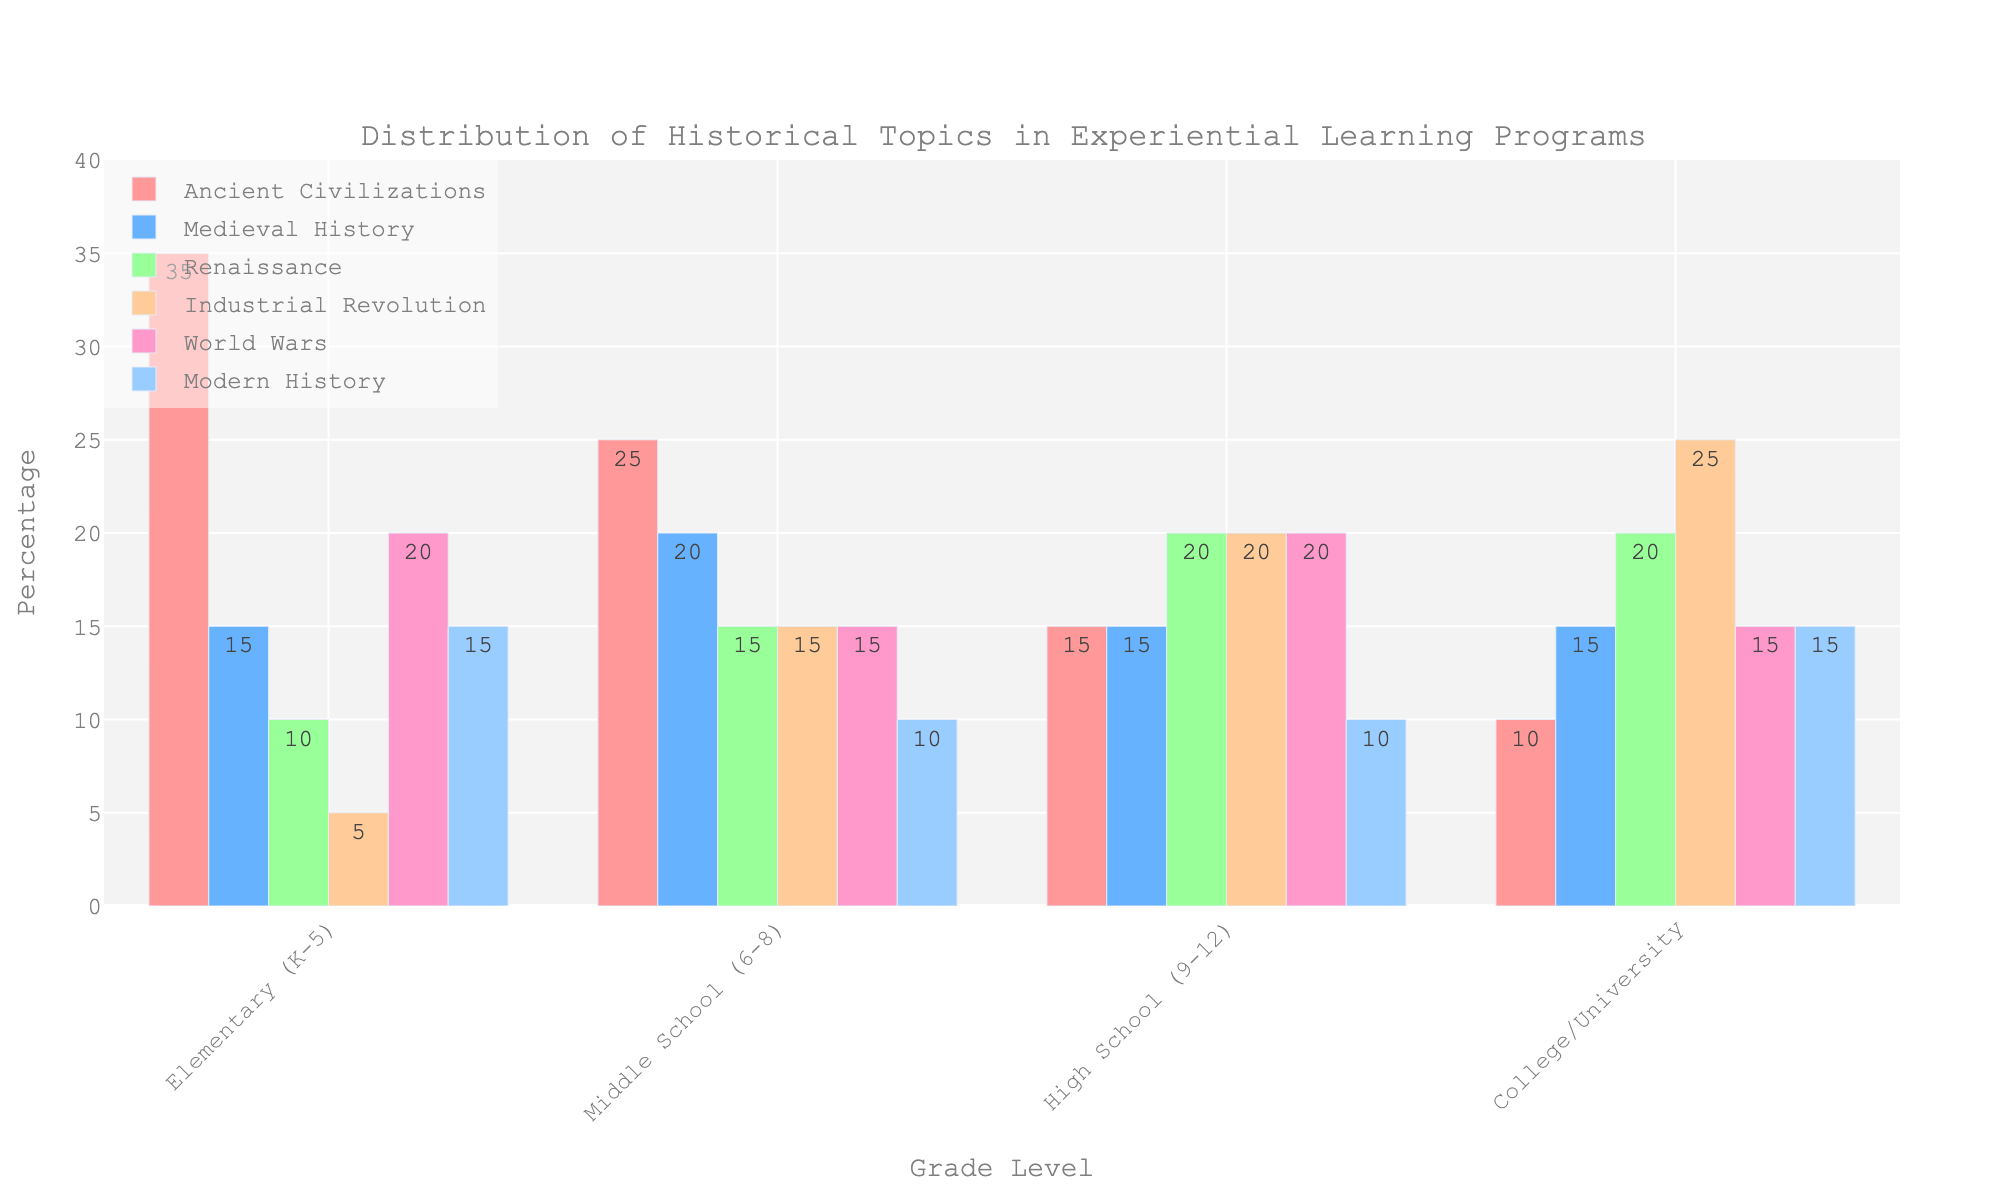Who teaches the most about the Industrial Revolution? By comparing the height of the bars for the Industrial Revolution category across all grade levels, we see that College/University has the tallest bar for this topic.
Answer: College/University Which grade level covers Medieval History and Renaissance equally? Look for the equal heights of the bars representing Medieval History and Renaissance. Both bars are equal in Middle School (6-8).
Answer: Middle School (6-8) Which topic is least covered by Elementary (K-5)? By checking the heights of the bars for each topic within the Elementary (K-5) category, we find that the Industrial Revolution has the shortest bar.
Answer: Industrial Revolution How many topics have a 15% coverage in High School (9-12)? Examine the heights of the bars within the High School (9-12) category and count those that reach the 15% mark. Medieval History, World Wars, and Modern History each have a 15% coverage.
Answer: 3 What is the total percentage of historical topics covered by Ancient Civilizations in Elementary (K-5) and Middle School (6-8)? Add the values of Ancient Civilizations for both Elementary (K-5) and Middle School (6-8). The values are 35% and 25% respectively. The total is 35 + 25 = 60.
Answer: 60% For which grade levels is Modern History covered equally? Compare the heights of the bars for Modern History across all grade levels and identify those with equal heights. Elementary (K-5) and Middle School (6-8) both have the same height bars for Modern History.
Answer: Elementary (K-5) and Middle School (6-8) What is the difference in coverage of the World Wars between Elementary (K-5) and College/University? Subtract the coverage of World Wars in College/University from that in Elementary (K-5). The values are 20% and 15% respectively. The difference is 20 - 15 = 5.
Answer: 5% Which historical topic is covered the most uniformly across all grade levels? Examine the bars for each topic and look for the one with the smallest range of heights across all grade levels. Renaissance has bars that are comparatively consistent across all levels.
Answer: Renaissance How does the coverage of Ancient Civilizations evolve from Elementary (K-5) to College/University? Observe the heights of the Ancient Civilizations bars across all grade levels. The trend shows a decrease from Elementary (K-5) to College/University (35 to 10).
Answer: Decreasing What is the average percentage of the Industrial Revolution covered across all grade levels? Add the Industrial Revolution values for all grade levels and then divide by the number of grade levels. The values are 5, 15, 20, and 25 which sum to 65. Dividing by 4 results in 16.25%.
Answer: 16.25% 